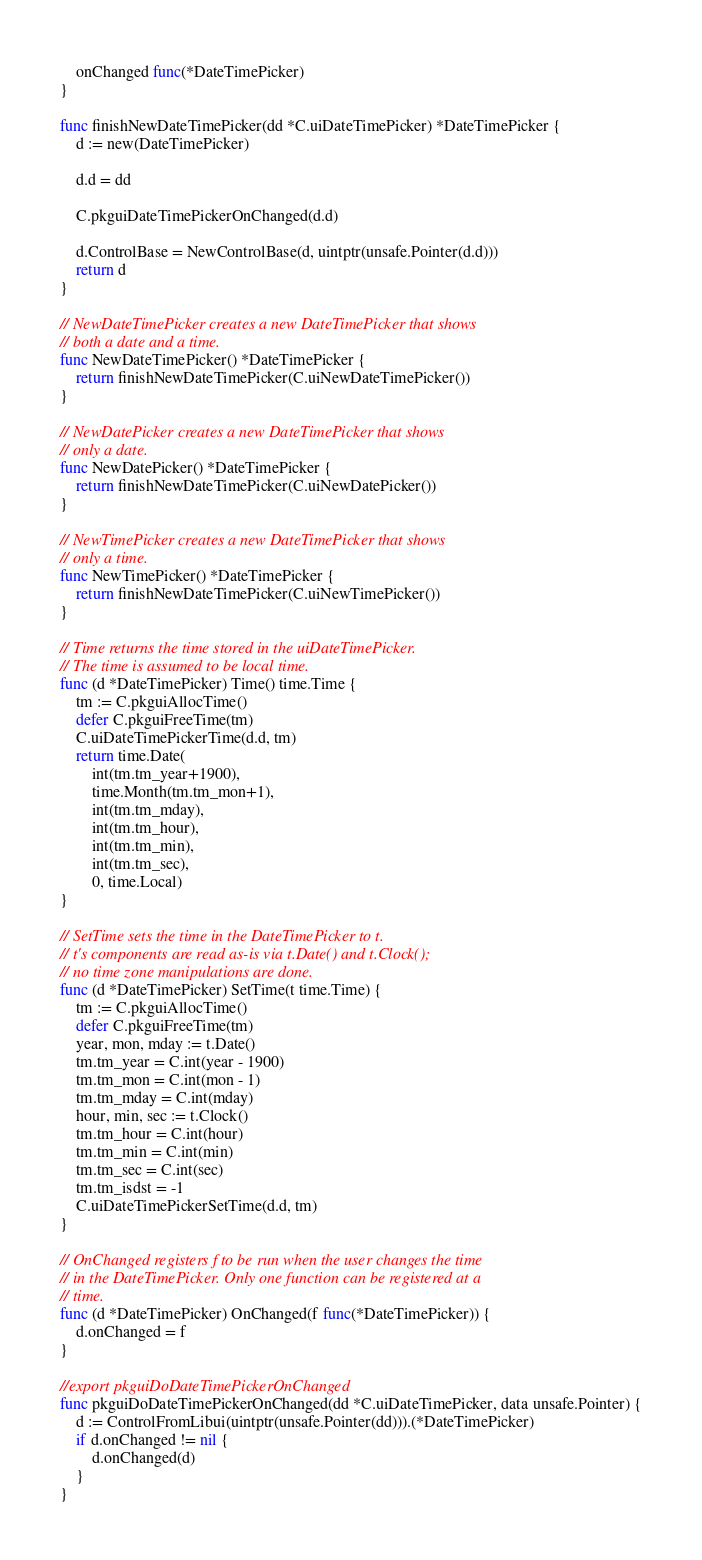<code> <loc_0><loc_0><loc_500><loc_500><_Go_>	onChanged func(*DateTimePicker)
}

func finishNewDateTimePicker(dd *C.uiDateTimePicker) *DateTimePicker {
	d := new(DateTimePicker)

	d.d = dd

	C.pkguiDateTimePickerOnChanged(d.d)

	d.ControlBase = NewControlBase(d, uintptr(unsafe.Pointer(d.d)))
	return d
}

// NewDateTimePicker creates a new DateTimePicker that shows
// both a date and a time.
func NewDateTimePicker() *DateTimePicker {
	return finishNewDateTimePicker(C.uiNewDateTimePicker())
}

// NewDatePicker creates a new DateTimePicker that shows
// only a date.
func NewDatePicker() *DateTimePicker {
	return finishNewDateTimePicker(C.uiNewDatePicker())
}

// NewTimePicker creates a new DateTimePicker that shows
// only a time.
func NewTimePicker() *DateTimePicker {
	return finishNewDateTimePicker(C.uiNewTimePicker())
}

// Time returns the time stored in the uiDateTimePicker.
// The time is assumed to be local time.
func (d *DateTimePicker) Time() time.Time {
	tm := C.pkguiAllocTime()
	defer C.pkguiFreeTime(tm)
	C.uiDateTimePickerTime(d.d, tm)
	return time.Date(
		int(tm.tm_year+1900),
		time.Month(tm.tm_mon+1),
		int(tm.tm_mday),
		int(tm.tm_hour),
		int(tm.tm_min),
		int(tm.tm_sec),
		0, time.Local)
}

// SetTime sets the time in the DateTimePicker to t.
// t's components are read as-is via t.Date() and t.Clock();
// no time zone manipulations are done.
func (d *DateTimePicker) SetTime(t time.Time) {
	tm := C.pkguiAllocTime()
	defer C.pkguiFreeTime(tm)
	year, mon, mday := t.Date()
	tm.tm_year = C.int(year - 1900)
	tm.tm_mon = C.int(mon - 1)
	tm.tm_mday = C.int(mday)
	hour, min, sec := t.Clock()
	tm.tm_hour = C.int(hour)
	tm.tm_min = C.int(min)
	tm.tm_sec = C.int(sec)
	tm.tm_isdst = -1
	C.uiDateTimePickerSetTime(d.d, tm)
}

// OnChanged registers f to be run when the user changes the time
// in the DateTimePicker. Only one function can be registered at a
// time.
func (d *DateTimePicker) OnChanged(f func(*DateTimePicker)) {
	d.onChanged = f
}

//export pkguiDoDateTimePickerOnChanged
func pkguiDoDateTimePickerOnChanged(dd *C.uiDateTimePicker, data unsafe.Pointer) {
	d := ControlFromLibui(uintptr(unsafe.Pointer(dd))).(*DateTimePicker)
	if d.onChanged != nil {
		d.onChanged(d)
	}
}
</code> 